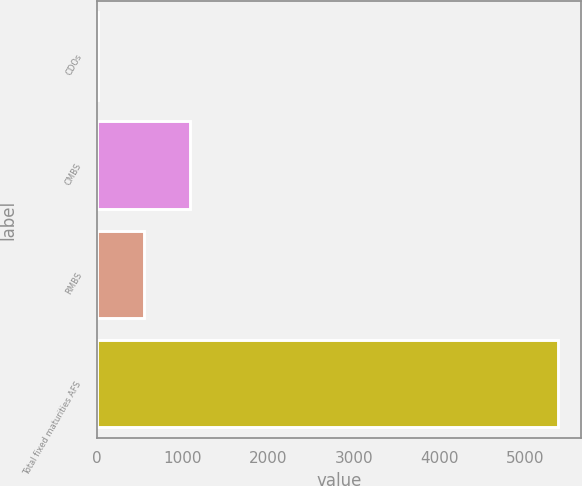Convert chart to OTSL. <chart><loc_0><loc_0><loc_500><loc_500><bar_chart><fcel>CDOs<fcel>CMBS<fcel>RMBS<fcel>Total fixed maturities AFS<nl><fcel>16<fcel>1087.6<fcel>551.8<fcel>5374<nl></chart> 